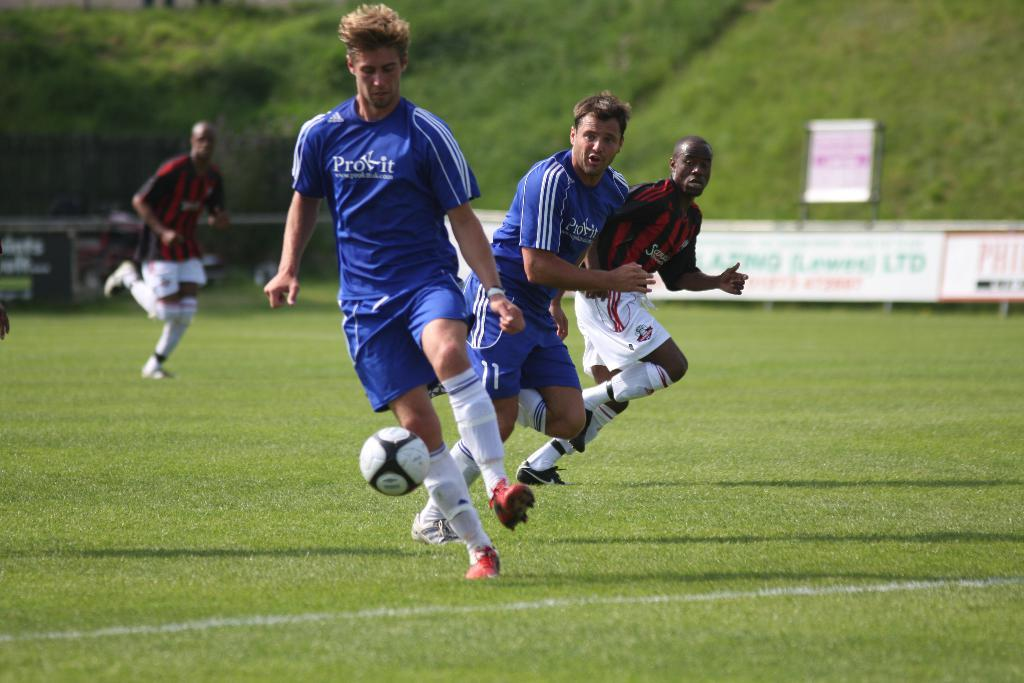What is happening in the image involving a group of people? The group of people are playing football. Can you describe the setting where the football game is taking place? The ground in the image has greenery. What type of fruit can be seen being passed between the players in the image? There is no fruit present in the image; the group of people are playing football. What type of agreement can be seen being signed by the players in the image? There is no agreement being signed in the image; the group of people are playing football. 